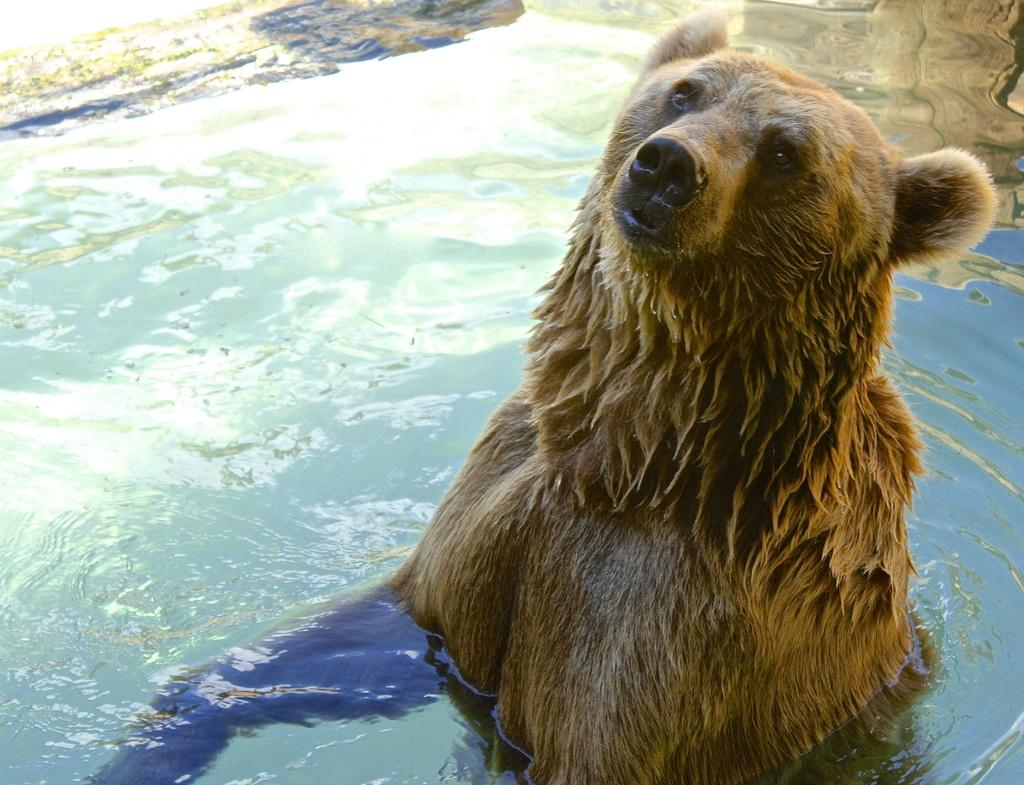What is in the water on the right side of the image? There is an animal in the water on the right side of the image. What is the condition of the animal in the image? The animal appears to be drowning. What can be seen in the background of the image? There are rocks visible in the background of the image. What is the primary element visible in the image? Water is visible in the image. What part of the man's body is visible in the image? There is no man present in the image; it features an animal in the water. What type of rifle can be seen in the image? There is no rifle present in the image. 